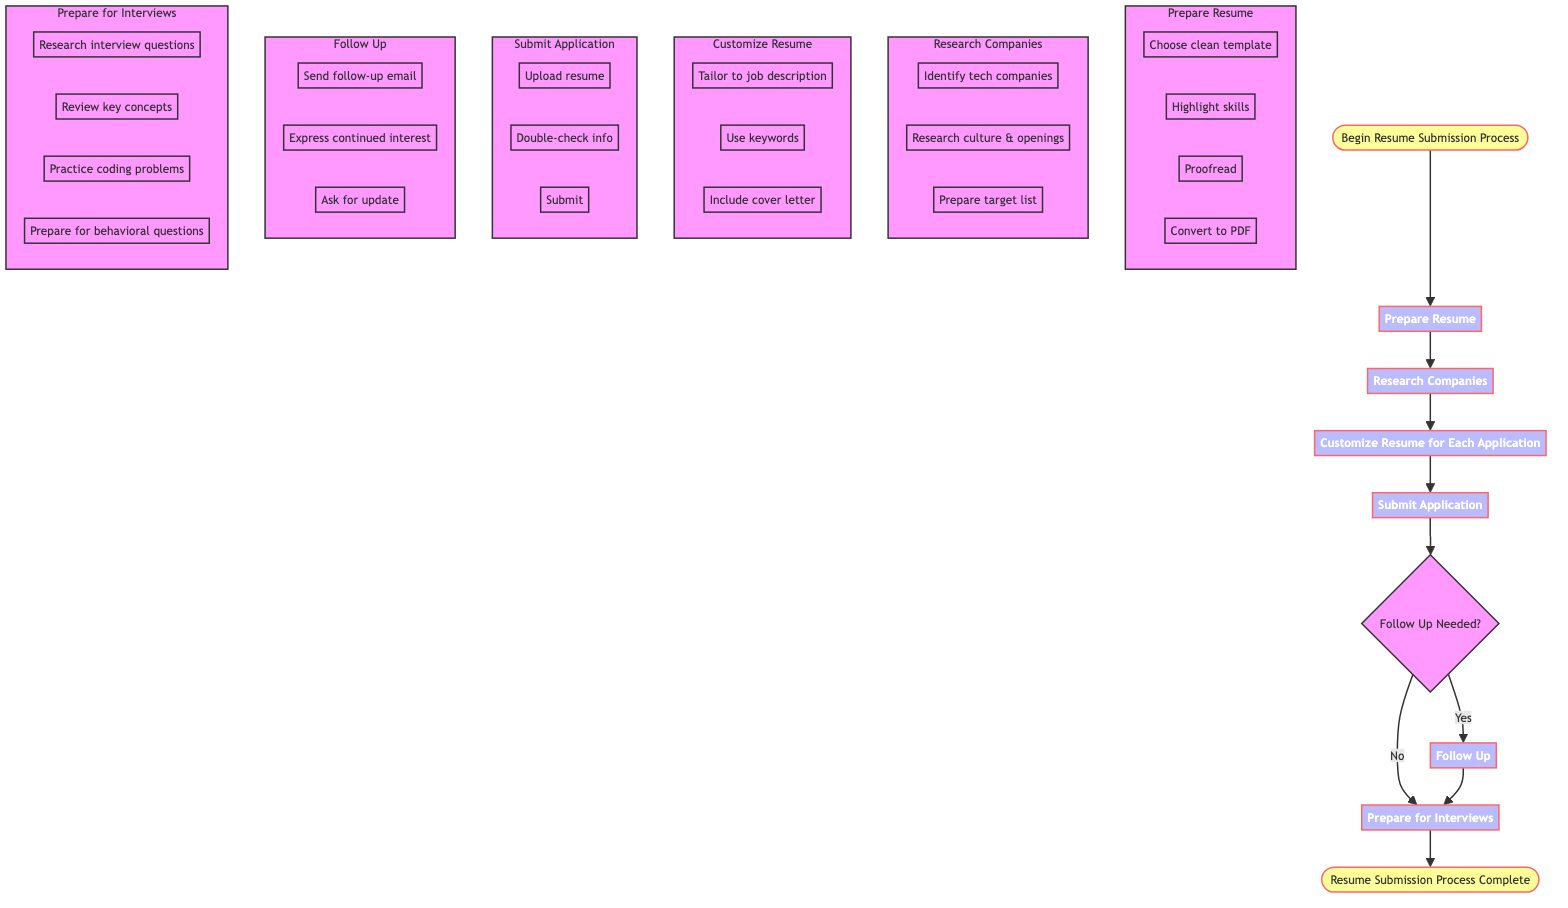What is the first step in the process? The diagram starts with the node labeled "Begin Resume Submission Process." This indicates the initial action required before any other steps are taken.
Answer: Begin Resume Submission Process How many main steps are there in the resume submission process? By counting the steps labeled from 'Prepare Resume' to 'Prepare for Interviews,' there are a total of six main steps in the process.
Answer: 6 What is the last step of the process? The final node in the flowchart indicates the conclusion of the process and is labeled "Resume Submission Process Complete." This signifies that all earlier steps have been successfully finished.
Answer: Resume Submission Process Complete What happens if follow-up is needed? If follow-up is needed, the process flows from the decision node labeled "Follow Up Needed?" to the step labeled "Follow Up," indicating that further actions are necessary after submitting the application.
Answer: Follow Up What must be done before submitting the application? Before submitting the application, the steps indicate that one must "Customize Resume for Each Application," suggesting that tailoring the resume is necessary.
Answer: Customize Resume for Each Application Which step involves researching interview questions? The step labeled "Prepare for Interviews" includes activities that entail researching interview questions. This step is crucial for preparing for the next phase of the job application process.
Answer: Prepare for Interviews What is the required action in "Follow Up"? The actions specified in this step include sending a follow-up email, expressing continued interest, and asking for an update on the application status, indicating that proactive communication is encouraged.
Answer: Send follow-up email How is the resume tailored for each application? The process requires tailoring the resume specifically to the job descriptions by using related keywords found within the job postings, ensuring that the resume directly addresses the requirements of each job.
Answer: Tailor to job description In what format should the resume be converted? According to the steps outlined in "Prepare Resume," converting the resume to PDF format is required before submission, ensuring compatibility and professionalism.
Answer: PDF format 